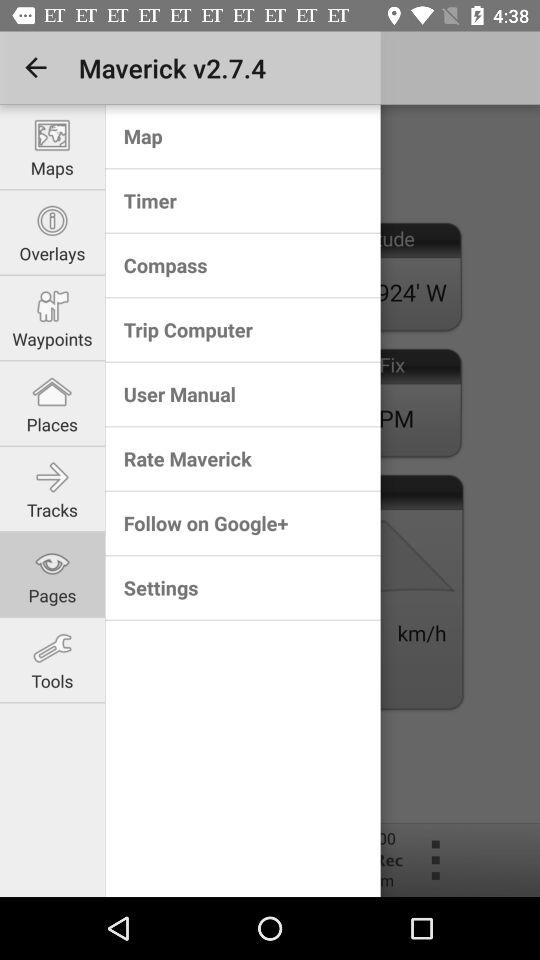Which tab is selected? The selected tab is "Pages". 